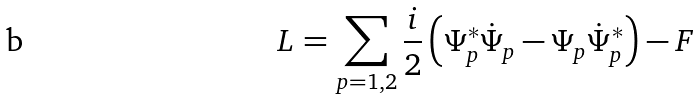<formula> <loc_0><loc_0><loc_500><loc_500>L = \sum _ { p = 1 , 2 } \frac { i } { 2 } \left ( \Psi _ { p } ^ { * } \dot { \Psi } _ { p } - \Psi _ { p } \dot { \Psi } _ { p } ^ { * } \right ) - F</formula> 